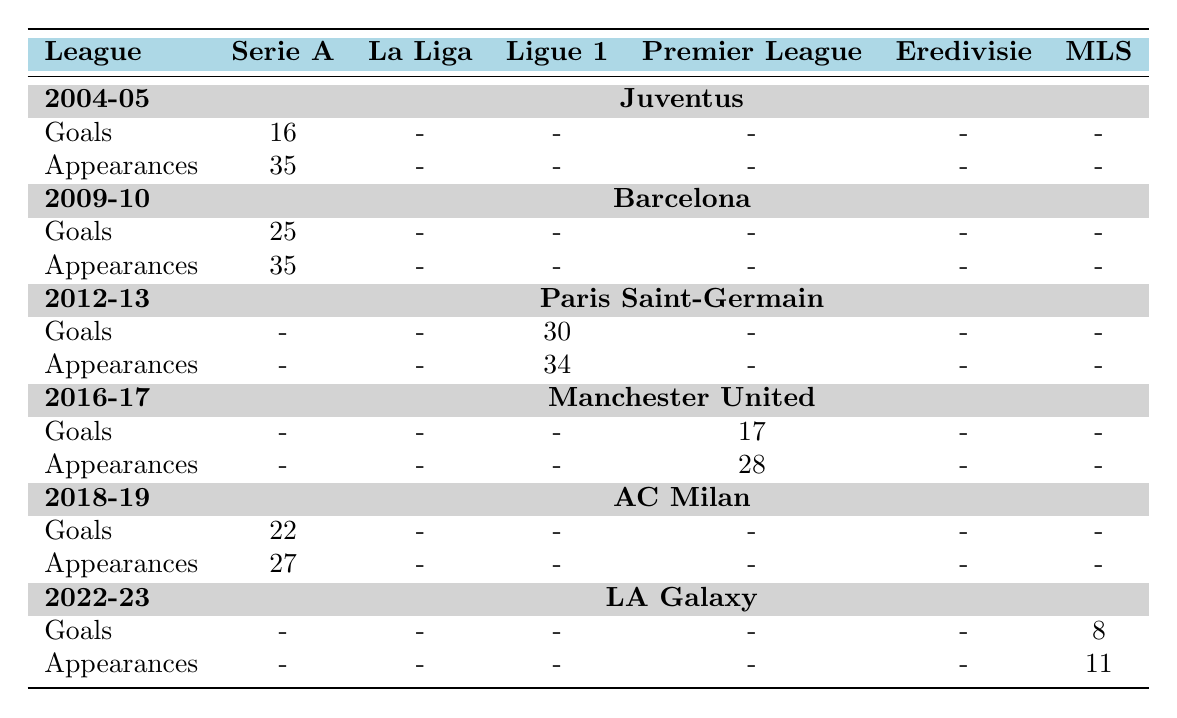What was Ibrahimovic's total goals in Serie A across the seasons shown? In the table, the goals scored by Ibrahimovic in Serie A are 16 (2004-05), 25 (2009-10), and 22 (2018-19). To find the total, add these values: 16 + 25 + 22 = 63.
Answer: 63 How many appearances did Ibrahimovic make in the Premier League during the 2016-17 season? The table shows that in the 2016-17 season, Ibrahimovic made 28 appearances in the Premier League for Manchester United.
Answer: 28 Did Ibrahimovic score any goals in La Liga during the seasons shown? According to the table, the goals scored in La Liga for all seasons listed are 0. Therefore, Ibrahimovic did not score any goals in La Liga during the specified seasons.
Answer: No Which league did Ibrahimovic score 30 goals in, and in which season? The table indicates that Ibrahimovic scored 30 goals in Ligue 1 during the 2012-13 season while playing for Paris Saint-Germain.
Answer: Ligue 1, 2012-13 What is the average number of goals Ibrahimovic scored per season in MLS? In MLS, Ibrahimovic scored 8 goals in the 2022-23 season. Since that is the only season mentioned with data, the average is simply 8 / 1 = 8.
Answer: 8 How many total goals did Ibrahimovic score from 2004-05 to 2022-23 across all leagues? Adding all the goals scored across all seasons and leagues: 16 + 25 + 30 + 17 + 22 + 8 = 118. Thus, the total number of goals is 118.
Answer: 118 What is the difference between Ibrahimovic's goals and appearances in the 2012-13 season? In the 2012-13 season, he scored 30 goals in Ligue 1 with 34 appearances. The difference between goals and appearances is 30 - 34 = -4.
Answer: -4 In which season did Ibrahimovic have the highest number of appearances in Serie A? According to the table, Ibrahimovic had 35 appearances in both the 2004-05 and 2009-10 seasons in Serie A, which is the highest for that league.
Answer: 2004-05 and 2009-10 Which league had no goals scored by Ibrahimovic in the table? The table indicates that there are no goals scored in La Liga and Eredivisie for all seasons shown. Thus, both leagues had no goals scored by Ibrahimovic.
Answer: La Liga and Eredivisie 